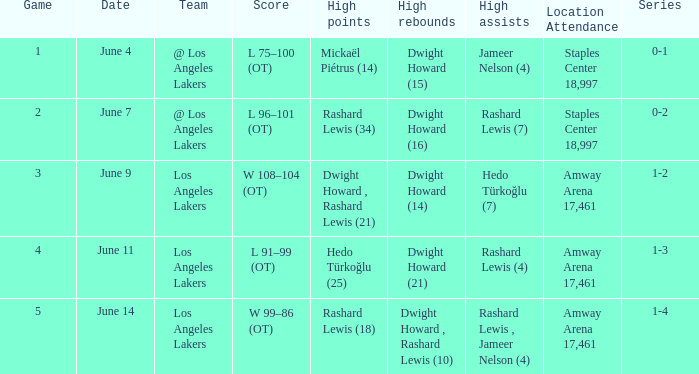What is High Assists, when High Rebounds is "Dwight Howard , Rashard Lewis (10)"? Rashard Lewis , Jameer Nelson (4). 